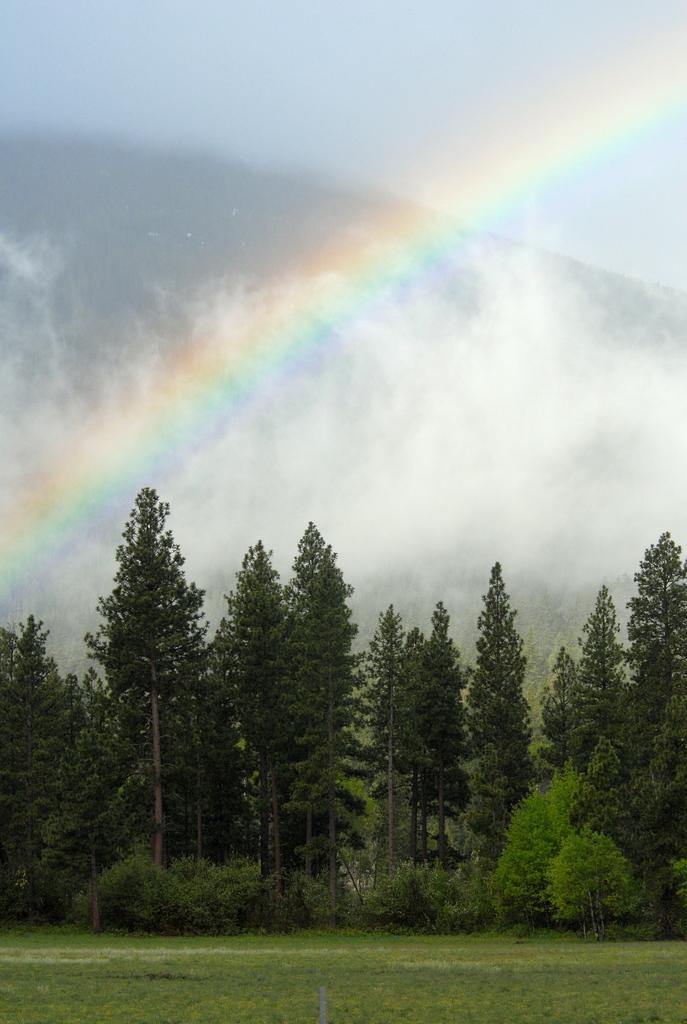How would you summarize this image in a sentence or two? In the picture we can see a grass surface far away from it we can see plants and trees and behind it we can see a rainbow in the sky. 